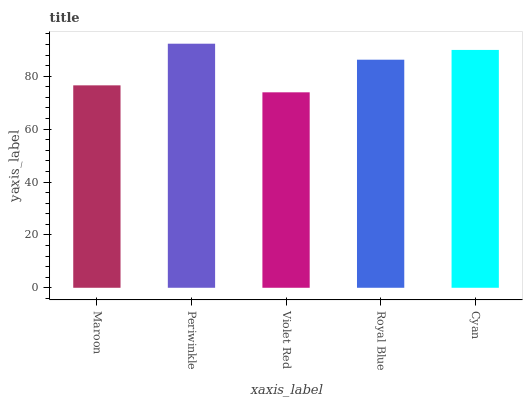Is Violet Red the minimum?
Answer yes or no. Yes. Is Periwinkle the maximum?
Answer yes or no. Yes. Is Periwinkle the minimum?
Answer yes or no. No. Is Violet Red the maximum?
Answer yes or no. No. Is Periwinkle greater than Violet Red?
Answer yes or no. Yes. Is Violet Red less than Periwinkle?
Answer yes or no. Yes. Is Violet Red greater than Periwinkle?
Answer yes or no. No. Is Periwinkle less than Violet Red?
Answer yes or no. No. Is Royal Blue the high median?
Answer yes or no. Yes. Is Royal Blue the low median?
Answer yes or no. Yes. Is Cyan the high median?
Answer yes or no. No. Is Violet Red the low median?
Answer yes or no. No. 